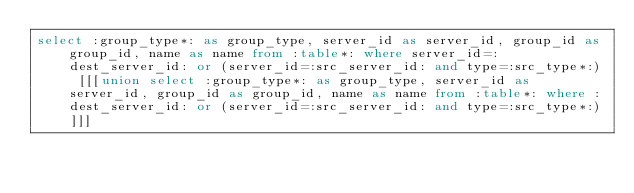Convert code to text. <code><loc_0><loc_0><loc_500><loc_500><_SQL_>select :group_type*: as group_type, server_id as server_id, group_id as group_id, name as name from :table*: where server_id=:dest_server_id: or (server_id=:src_server_id: and type=:src_type*:) [[[union select :group_type*: as group_type, server_id as server_id, group_id as group_id, name as name from :table*: where :dest_server_id: or (server_id=:src_server_id: and type=:src_type*:)]]]</code> 